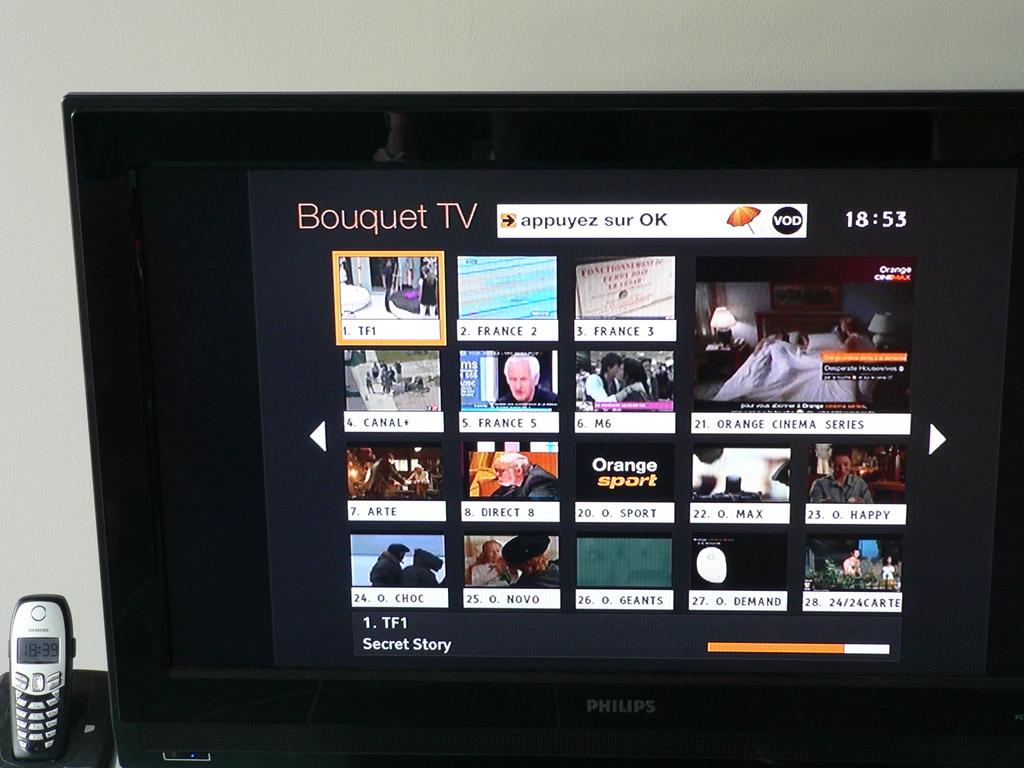What is on tv?
Your answer should be compact. Bouquet tv. What time is it?
Ensure brevity in your answer.  18:53. 